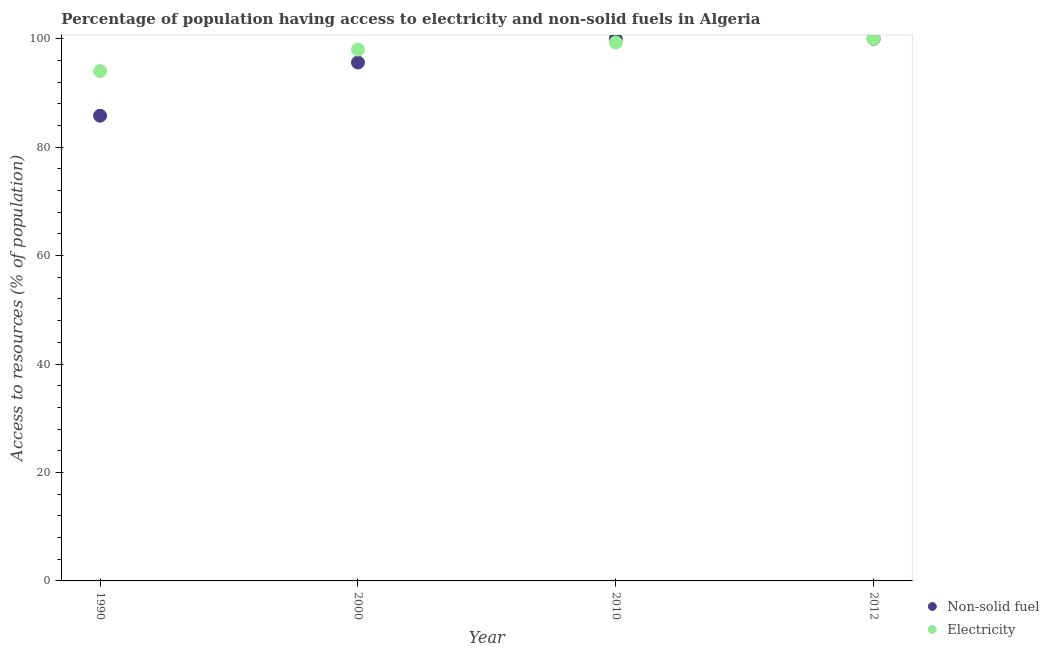What is the percentage of population having access to non-solid fuel in 2000?
Ensure brevity in your answer.  95.61. Across all years, what is the maximum percentage of population having access to non-solid fuel?
Offer a terse response. 99.99. Across all years, what is the minimum percentage of population having access to electricity?
Your answer should be compact. 94.04. In which year was the percentage of population having access to non-solid fuel maximum?
Provide a short and direct response. 2012. What is the total percentage of population having access to electricity in the graph?
Provide a succinct answer. 391.34. What is the difference between the percentage of population having access to electricity in 1990 and that in 2012?
Give a very brief answer. -5.96. What is the difference between the percentage of population having access to electricity in 2010 and the percentage of population having access to non-solid fuel in 1990?
Ensure brevity in your answer.  13.5. What is the average percentage of population having access to electricity per year?
Provide a short and direct response. 97.83. In the year 2010, what is the difference between the percentage of population having access to non-solid fuel and percentage of population having access to electricity?
Provide a succinct answer. 0.66. In how many years, is the percentage of population having access to non-solid fuel greater than 36 %?
Offer a terse response. 4. What is the ratio of the percentage of population having access to electricity in 2000 to that in 2010?
Your answer should be compact. 0.99. Is the difference between the percentage of population having access to non-solid fuel in 1990 and 2000 greater than the difference between the percentage of population having access to electricity in 1990 and 2000?
Your answer should be very brief. No. What is the difference between the highest and the second highest percentage of population having access to non-solid fuel?
Your answer should be very brief. 0.03. What is the difference between the highest and the lowest percentage of population having access to non-solid fuel?
Provide a short and direct response. 14.19. In how many years, is the percentage of population having access to electricity greater than the average percentage of population having access to electricity taken over all years?
Your answer should be compact. 3. Is the sum of the percentage of population having access to electricity in 1990 and 2010 greater than the maximum percentage of population having access to non-solid fuel across all years?
Your answer should be compact. Yes. Is the percentage of population having access to electricity strictly greater than the percentage of population having access to non-solid fuel over the years?
Offer a very short reply. No. How many dotlines are there?
Provide a succinct answer. 2. How many years are there in the graph?
Offer a terse response. 4. Are the values on the major ticks of Y-axis written in scientific E-notation?
Provide a short and direct response. No. Does the graph contain any zero values?
Keep it short and to the point. No. Where does the legend appear in the graph?
Make the answer very short. Bottom right. How are the legend labels stacked?
Keep it short and to the point. Vertical. What is the title of the graph?
Your response must be concise. Percentage of population having access to electricity and non-solid fuels in Algeria. Does "Forest land" appear as one of the legend labels in the graph?
Keep it short and to the point. No. What is the label or title of the X-axis?
Offer a terse response. Year. What is the label or title of the Y-axis?
Offer a very short reply. Access to resources (% of population). What is the Access to resources (% of population) in Non-solid fuel in 1990?
Make the answer very short. 85.8. What is the Access to resources (% of population) of Electricity in 1990?
Provide a short and direct response. 94.04. What is the Access to resources (% of population) in Non-solid fuel in 2000?
Your answer should be compact. 95.61. What is the Access to resources (% of population) of Electricity in 2000?
Provide a short and direct response. 98. What is the Access to resources (% of population) in Non-solid fuel in 2010?
Ensure brevity in your answer.  99.96. What is the Access to resources (% of population) of Electricity in 2010?
Provide a succinct answer. 99.3. What is the Access to resources (% of population) of Non-solid fuel in 2012?
Your answer should be very brief. 99.99. Across all years, what is the maximum Access to resources (% of population) in Non-solid fuel?
Your response must be concise. 99.99. Across all years, what is the minimum Access to resources (% of population) in Non-solid fuel?
Keep it short and to the point. 85.8. Across all years, what is the minimum Access to resources (% of population) in Electricity?
Make the answer very short. 94.04. What is the total Access to resources (% of population) of Non-solid fuel in the graph?
Keep it short and to the point. 381.37. What is the total Access to resources (% of population) in Electricity in the graph?
Keep it short and to the point. 391.34. What is the difference between the Access to resources (% of population) in Non-solid fuel in 1990 and that in 2000?
Keep it short and to the point. -9.81. What is the difference between the Access to resources (% of population) of Electricity in 1990 and that in 2000?
Your answer should be very brief. -3.96. What is the difference between the Access to resources (% of population) in Non-solid fuel in 1990 and that in 2010?
Offer a terse response. -14.16. What is the difference between the Access to resources (% of population) of Electricity in 1990 and that in 2010?
Give a very brief answer. -5.26. What is the difference between the Access to resources (% of population) in Non-solid fuel in 1990 and that in 2012?
Offer a very short reply. -14.19. What is the difference between the Access to resources (% of population) of Electricity in 1990 and that in 2012?
Provide a succinct answer. -5.96. What is the difference between the Access to resources (% of population) in Non-solid fuel in 2000 and that in 2010?
Ensure brevity in your answer.  -4.35. What is the difference between the Access to resources (% of population) of Electricity in 2000 and that in 2010?
Ensure brevity in your answer.  -1.3. What is the difference between the Access to resources (% of population) in Non-solid fuel in 2000 and that in 2012?
Your answer should be compact. -4.38. What is the difference between the Access to resources (% of population) of Non-solid fuel in 2010 and that in 2012?
Offer a terse response. -0.03. What is the difference between the Access to resources (% of population) of Electricity in 2010 and that in 2012?
Offer a terse response. -0.7. What is the difference between the Access to resources (% of population) of Non-solid fuel in 1990 and the Access to resources (% of population) of Electricity in 2000?
Provide a succinct answer. -12.2. What is the difference between the Access to resources (% of population) of Non-solid fuel in 1990 and the Access to resources (% of population) of Electricity in 2010?
Offer a terse response. -13.49. What is the difference between the Access to resources (% of population) in Non-solid fuel in 1990 and the Access to resources (% of population) in Electricity in 2012?
Keep it short and to the point. -14.2. What is the difference between the Access to resources (% of population) of Non-solid fuel in 2000 and the Access to resources (% of population) of Electricity in 2010?
Offer a terse response. -3.69. What is the difference between the Access to resources (% of population) of Non-solid fuel in 2000 and the Access to resources (% of population) of Electricity in 2012?
Provide a succinct answer. -4.39. What is the difference between the Access to resources (% of population) in Non-solid fuel in 2010 and the Access to resources (% of population) in Electricity in 2012?
Keep it short and to the point. -0.04. What is the average Access to resources (% of population) of Non-solid fuel per year?
Provide a succinct answer. 95.34. What is the average Access to resources (% of population) in Electricity per year?
Your answer should be compact. 97.83. In the year 1990, what is the difference between the Access to resources (% of population) of Non-solid fuel and Access to resources (% of population) of Electricity?
Make the answer very short. -8.23. In the year 2000, what is the difference between the Access to resources (% of population) of Non-solid fuel and Access to resources (% of population) of Electricity?
Give a very brief answer. -2.39. In the year 2010, what is the difference between the Access to resources (% of population) of Non-solid fuel and Access to resources (% of population) of Electricity?
Offer a terse response. 0.66. In the year 2012, what is the difference between the Access to resources (% of population) of Non-solid fuel and Access to resources (% of population) of Electricity?
Keep it short and to the point. -0.01. What is the ratio of the Access to resources (% of population) in Non-solid fuel in 1990 to that in 2000?
Offer a terse response. 0.9. What is the ratio of the Access to resources (% of population) in Electricity in 1990 to that in 2000?
Keep it short and to the point. 0.96. What is the ratio of the Access to resources (% of population) in Non-solid fuel in 1990 to that in 2010?
Keep it short and to the point. 0.86. What is the ratio of the Access to resources (% of population) in Electricity in 1990 to that in 2010?
Offer a very short reply. 0.95. What is the ratio of the Access to resources (% of population) of Non-solid fuel in 1990 to that in 2012?
Offer a very short reply. 0.86. What is the ratio of the Access to resources (% of population) in Electricity in 1990 to that in 2012?
Give a very brief answer. 0.94. What is the ratio of the Access to resources (% of population) of Non-solid fuel in 2000 to that in 2010?
Your answer should be compact. 0.96. What is the ratio of the Access to resources (% of population) of Electricity in 2000 to that in 2010?
Provide a succinct answer. 0.99. What is the ratio of the Access to resources (% of population) of Non-solid fuel in 2000 to that in 2012?
Your answer should be very brief. 0.96. What is the ratio of the Access to resources (% of population) of Electricity in 2000 to that in 2012?
Ensure brevity in your answer.  0.98. What is the ratio of the Access to resources (% of population) in Electricity in 2010 to that in 2012?
Your answer should be very brief. 0.99. What is the difference between the highest and the second highest Access to resources (% of population) in Non-solid fuel?
Your answer should be compact. 0.03. What is the difference between the highest and the lowest Access to resources (% of population) in Non-solid fuel?
Offer a very short reply. 14.19. What is the difference between the highest and the lowest Access to resources (% of population) in Electricity?
Keep it short and to the point. 5.96. 